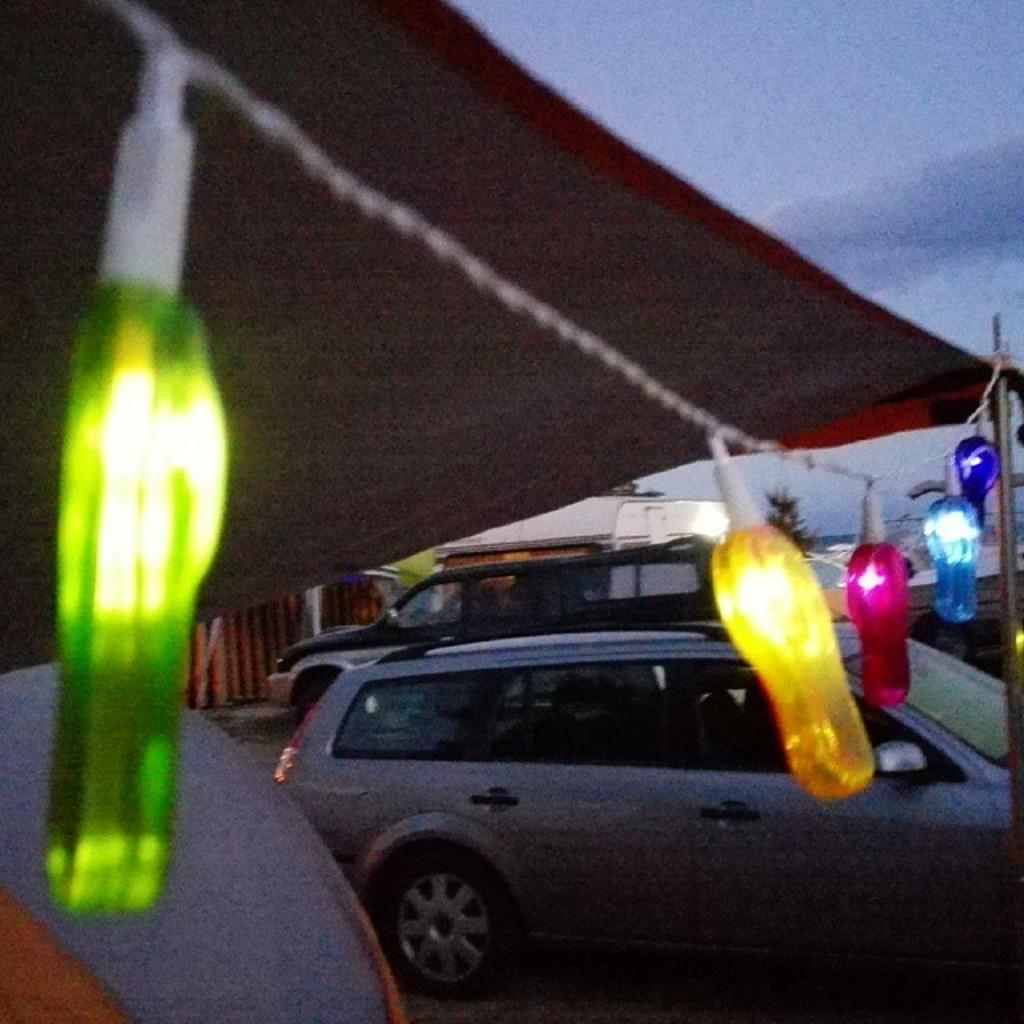What type of vehicles can be seen in the image? There are cars in the image. What else is present in the image besides the cars? There are lights tied to poles in the image. What colors are the lights? The lights have colors: pink, red, yellow, and blue. What type of nerve is present in the image? There is no nerve present in the image; it features cars and lights tied to poles. What type of rail can be seen in the image? There is no rail present in the image. 